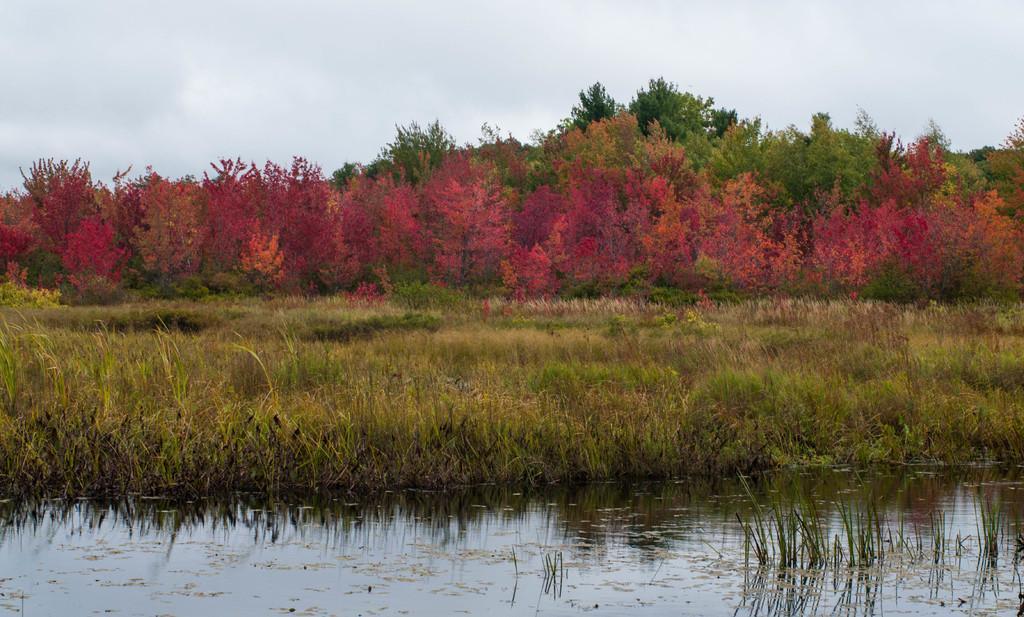Describe this image in one or two sentences. In this image at the bottom there is pond and some plants, in the background there are some trees and flowers. At the top of the image there is sky. 